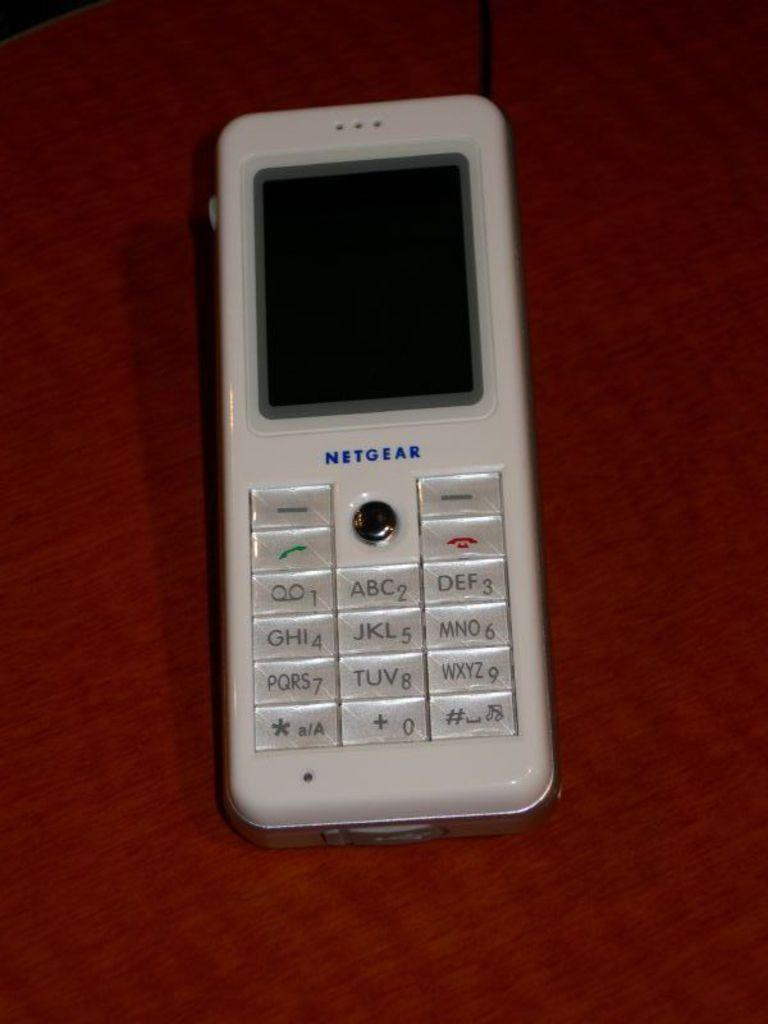<image>
Render a clear and concise summary of the photo. older white netgear phone turned off on a red background 